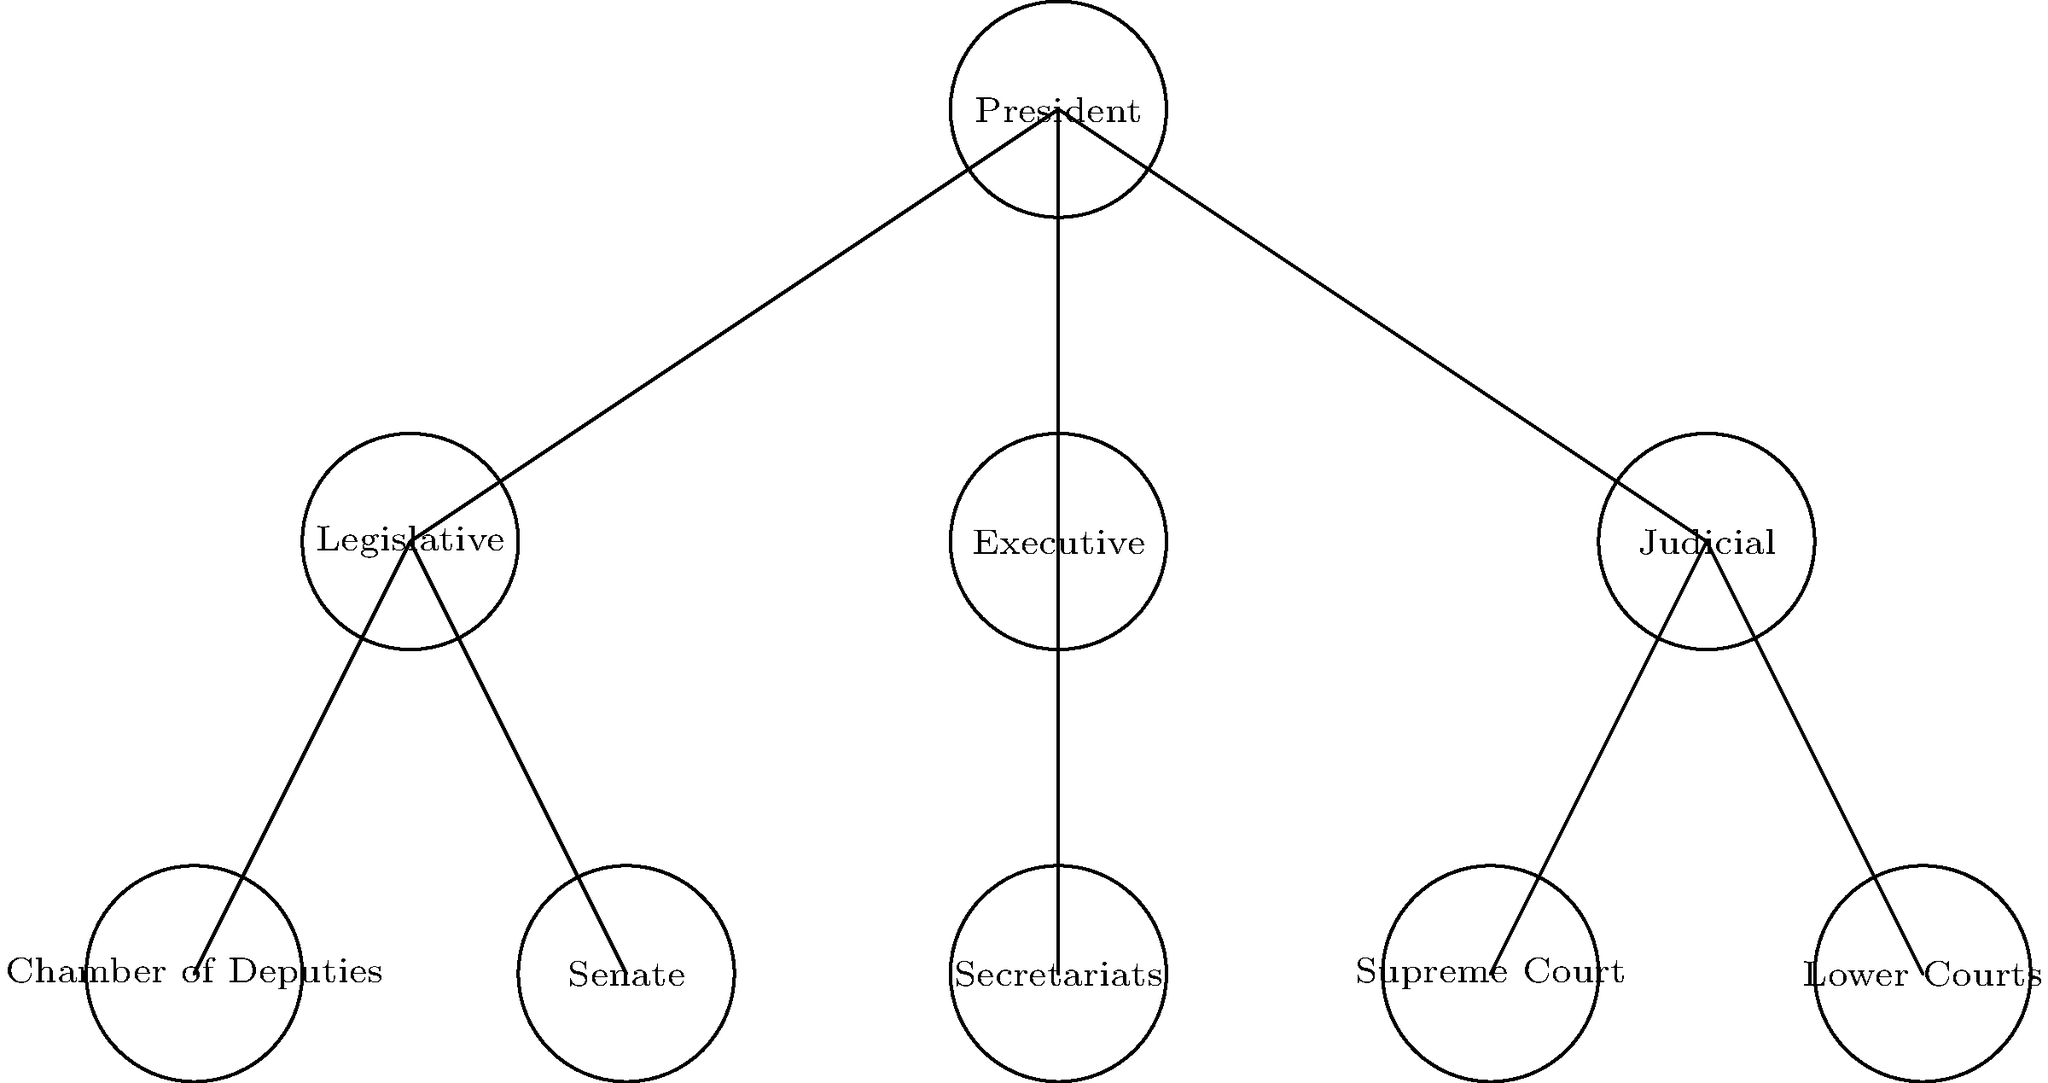Based on the organizational chart of Mexico's government structure, which branch of government is responsible for interpreting laws and resolving legal disputes, and what are its two main components? To answer this question, let's analyze the organizational chart step-by-step:

1. The chart shows three main branches directly under the President: Legislative, Executive, and Judicial.

2. Each branch has its specific roles and components:
   - Legislative: Chamber of Deputies and Senate
   - Executive: Secretariats
   - Judicial: Supreme Court and Lower Courts

3. The question asks about the branch responsible for interpreting laws and resolving legal disputes. This is typically the role of the Judicial branch in most government systems.

4. Looking at the Judicial branch in the chart, we can see it has two main components:
   a. Supreme Court
   b. Lower Courts

5. These two components form the hierarchy of the court system, with the Supreme Court at the top and Lower Courts handling cases at various levels below it.

Therefore, the branch responsible for interpreting laws and resolving legal disputes is the Judicial branch, and its two main components are the Supreme Court and Lower Courts.
Answer: Judicial branch; Supreme Court and Lower Courts 